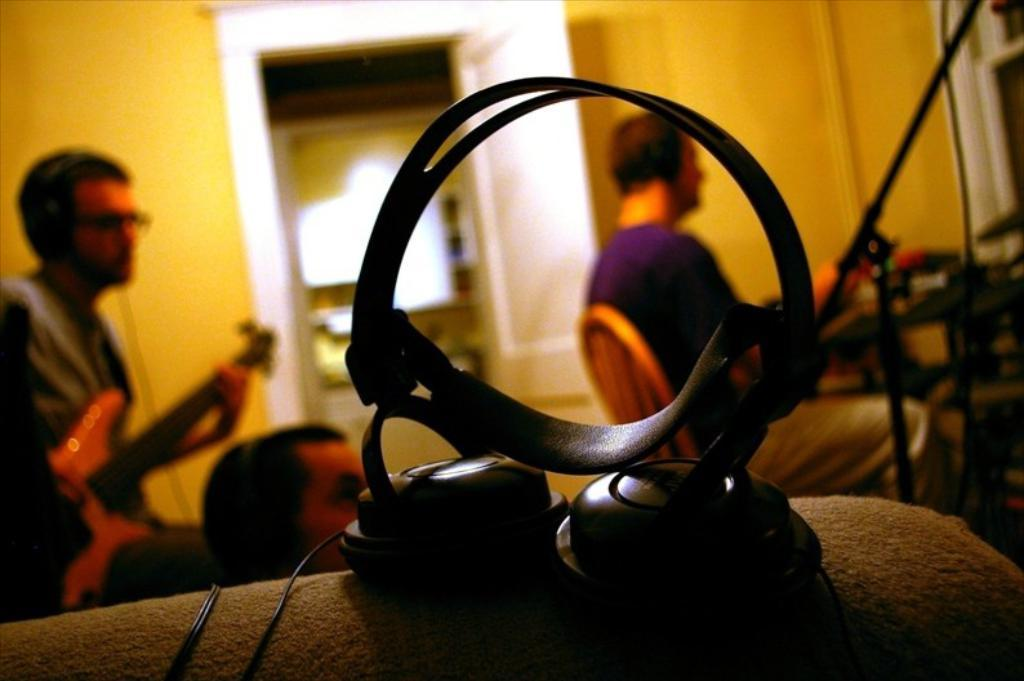What device is visible in the image? There is a headset in the image. How many people are in the room? There are three people in the room. What is one of the people doing in the image? A person is playing a guitar on the left side of the image. What can be seen in the background of the image? There is a white door in the background of the image. What type of pollution can be seen coming from the headset in the image? There is no pollution visible in the image, as it features a headset and people playing music. 